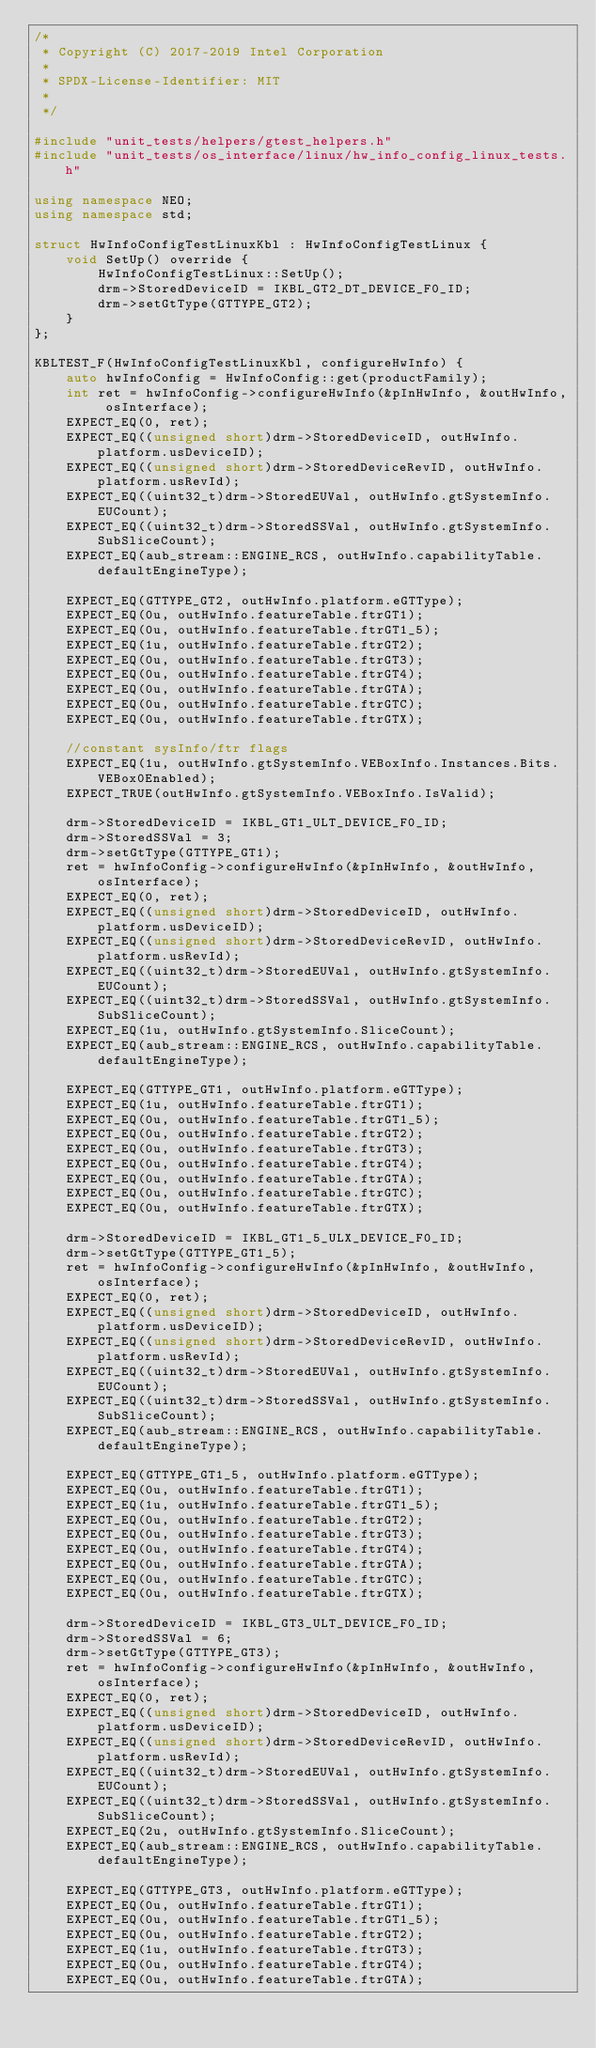<code> <loc_0><loc_0><loc_500><loc_500><_C++_>/*
 * Copyright (C) 2017-2019 Intel Corporation
 *
 * SPDX-License-Identifier: MIT
 *
 */

#include "unit_tests/helpers/gtest_helpers.h"
#include "unit_tests/os_interface/linux/hw_info_config_linux_tests.h"

using namespace NEO;
using namespace std;

struct HwInfoConfigTestLinuxKbl : HwInfoConfigTestLinux {
    void SetUp() override {
        HwInfoConfigTestLinux::SetUp();
        drm->StoredDeviceID = IKBL_GT2_DT_DEVICE_F0_ID;
        drm->setGtType(GTTYPE_GT2);
    }
};

KBLTEST_F(HwInfoConfigTestLinuxKbl, configureHwInfo) {
    auto hwInfoConfig = HwInfoConfig::get(productFamily);
    int ret = hwInfoConfig->configureHwInfo(&pInHwInfo, &outHwInfo, osInterface);
    EXPECT_EQ(0, ret);
    EXPECT_EQ((unsigned short)drm->StoredDeviceID, outHwInfo.platform.usDeviceID);
    EXPECT_EQ((unsigned short)drm->StoredDeviceRevID, outHwInfo.platform.usRevId);
    EXPECT_EQ((uint32_t)drm->StoredEUVal, outHwInfo.gtSystemInfo.EUCount);
    EXPECT_EQ((uint32_t)drm->StoredSSVal, outHwInfo.gtSystemInfo.SubSliceCount);
    EXPECT_EQ(aub_stream::ENGINE_RCS, outHwInfo.capabilityTable.defaultEngineType);

    EXPECT_EQ(GTTYPE_GT2, outHwInfo.platform.eGTType);
    EXPECT_EQ(0u, outHwInfo.featureTable.ftrGT1);
    EXPECT_EQ(0u, outHwInfo.featureTable.ftrGT1_5);
    EXPECT_EQ(1u, outHwInfo.featureTable.ftrGT2);
    EXPECT_EQ(0u, outHwInfo.featureTable.ftrGT3);
    EXPECT_EQ(0u, outHwInfo.featureTable.ftrGT4);
    EXPECT_EQ(0u, outHwInfo.featureTable.ftrGTA);
    EXPECT_EQ(0u, outHwInfo.featureTable.ftrGTC);
    EXPECT_EQ(0u, outHwInfo.featureTable.ftrGTX);

    //constant sysInfo/ftr flags
    EXPECT_EQ(1u, outHwInfo.gtSystemInfo.VEBoxInfo.Instances.Bits.VEBox0Enabled);
    EXPECT_TRUE(outHwInfo.gtSystemInfo.VEBoxInfo.IsValid);

    drm->StoredDeviceID = IKBL_GT1_ULT_DEVICE_F0_ID;
    drm->StoredSSVal = 3;
    drm->setGtType(GTTYPE_GT1);
    ret = hwInfoConfig->configureHwInfo(&pInHwInfo, &outHwInfo, osInterface);
    EXPECT_EQ(0, ret);
    EXPECT_EQ((unsigned short)drm->StoredDeviceID, outHwInfo.platform.usDeviceID);
    EXPECT_EQ((unsigned short)drm->StoredDeviceRevID, outHwInfo.platform.usRevId);
    EXPECT_EQ((uint32_t)drm->StoredEUVal, outHwInfo.gtSystemInfo.EUCount);
    EXPECT_EQ((uint32_t)drm->StoredSSVal, outHwInfo.gtSystemInfo.SubSliceCount);
    EXPECT_EQ(1u, outHwInfo.gtSystemInfo.SliceCount);
    EXPECT_EQ(aub_stream::ENGINE_RCS, outHwInfo.capabilityTable.defaultEngineType);

    EXPECT_EQ(GTTYPE_GT1, outHwInfo.platform.eGTType);
    EXPECT_EQ(1u, outHwInfo.featureTable.ftrGT1);
    EXPECT_EQ(0u, outHwInfo.featureTable.ftrGT1_5);
    EXPECT_EQ(0u, outHwInfo.featureTable.ftrGT2);
    EXPECT_EQ(0u, outHwInfo.featureTable.ftrGT3);
    EXPECT_EQ(0u, outHwInfo.featureTable.ftrGT4);
    EXPECT_EQ(0u, outHwInfo.featureTable.ftrGTA);
    EXPECT_EQ(0u, outHwInfo.featureTable.ftrGTC);
    EXPECT_EQ(0u, outHwInfo.featureTable.ftrGTX);

    drm->StoredDeviceID = IKBL_GT1_5_ULX_DEVICE_F0_ID;
    drm->setGtType(GTTYPE_GT1_5);
    ret = hwInfoConfig->configureHwInfo(&pInHwInfo, &outHwInfo, osInterface);
    EXPECT_EQ(0, ret);
    EXPECT_EQ((unsigned short)drm->StoredDeviceID, outHwInfo.platform.usDeviceID);
    EXPECT_EQ((unsigned short)drm->StoredDeviceRevID, outHwInfo.platform.usRevId);
    EXPECT_EQ((uint32_t)drm->StoredEUVal, outHwInfo.gtSystemInfo.EUCount);
    EXPECT_EQ((uint32_t)drm->StoredSSVal, outHwInfo.gtSystemInfo.SubSliceCount);
    EXPECT_EQ(aub_stream::ENGINE_RCS, outHwInfo.capabilityTable.defaultEngineType);

    EXPECT_EQ(GTTYPE_GT1_5, outHwInfo.platform.eGTType);
    EXPECT_EQ(0u, outHwInfo.featureTable.ftrGT1);
    EXPECT_EQ(1u, outHwInfo.featureTable.ftrGT1_5);
    EXPECT_EQ(0u, outHwInfo.featureTable.ftrGT2);
    EXPECT_EQ(0u, outHwInfo.featureTable.ftrGT3);
    EXPECT_EQ(0u, outHwInfo.featureTable.ftrGT4);
    EXPECT_EQ(0u, outHwInfo.featureTable.ftrGTA);
    EXPECT_EQ(0u, outHwInfo.featureTable.ftrGTC);
    EXPECT_EQ(0u, outHwInfo.featureTable.ftrGTX);

    drm->StoredDeviceID = IKBL_GT3_ULT_DEVICE_F0_ID;
    drm->StoredSSVal = 6;
    drm->setGtType(GTTYPE_GT3);
    ret = hwInfoConfig->configureHwInfo(&pInHwInfo, &outHwInfo, osInterface);
    EXPECT_EQ(0, ret);
    EXPECT_EQ((unsigned short)drm->StoredDeviceID, outHwInfo.platform.usDeviceID);
    EXPECT_EQ((unsigned short)drm->StoredDeviceRevID, outHwInfo.platform.usRevId);
    EXPECT_EQ((uint32_t)drm->StoredEUVal, outHwInfo.gtSystemInfo.EUCount);
    EXPECT_EQ((uint32_t)drm->StoredSSVal, outHwInfo.gtSystemInfo.SubSliceCount);
    EXPECT_EQ(2u, outHwInfo.gtSystemInfo.SliceCount);
    EXPECT_EQ(aub_stream::ENGINE_RCS, outHwInfo.capabilityTable.defaultEngineType);

    EXPECT_EQ(GTTYPE_GT3, outHwInfo.platform.eGTType);
    EXPECT_EQ(0u, outHwInfo.featureTable.ftrGT1);
    EXPECT_EQ(0u, outHwInfo.featureTable.ftrGT1_5);
    EXPECT_EQ(0u, outHwInfo.featureTable.ftrGT2);
    EXPECT_EQ(1u, outHwInfo.featureTable.ftrGT3);
    EXPECT_EQ(0u, outHwInfo.featureTable.ftrGT4);
    EXPECT_EQ(0u, outHwInfo.featureTable.ftrGTA);</code> 